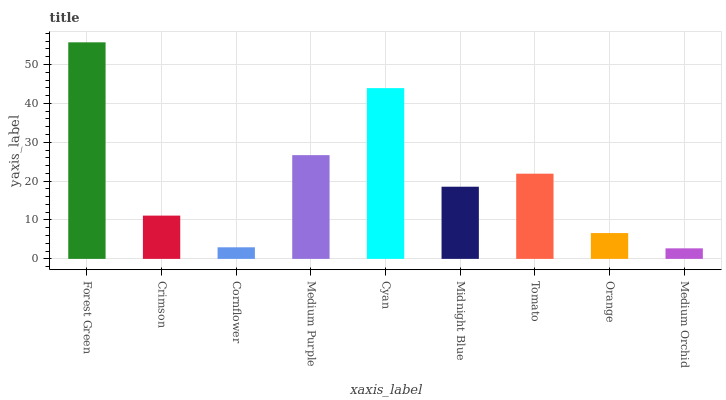Is Medium Orchid the minimum?
Answer yes or no. Yes. Is Forest Green the maximum?
Answer yes or no. Yes. Is Crimson the minimum?
Answer yes or no. No. Is Crimson the maximum?
Answer yes or no. No. Is Forest Green greater than Crimson?
Answer yes or no. Yes. Is Crimson less than Forest Green?
Answer yes or no. Yes. Is Crimson greater than Forest Green?
Answer yes or no. No. Is Forest Green less than Crimson?
Answer yes or no. No. Is Midnight Blue the high median?
Answer yes or no. Yes. Is Midnight Blue the low median?
Answer yes or no. Yes. Is Forest Green the high median?
Answer yes or no. No. Is Cornflower the low median?
Answer yes or no. No. 